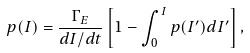<formula> <loc_0><loc_0><loc_500><loc_500>p ( I ) = \frac { \Gamma _ { E } } { d I / d t } \left [ 1 - \int _ { 0 } ^ { I } p ( I ^ { \prime } ) d I ^ { \prime } \right ] ,</formula> 